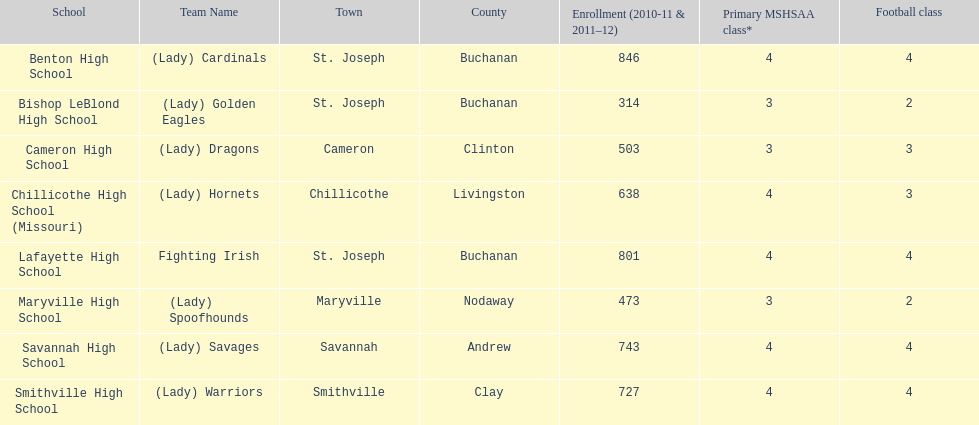How many of the schools had at least 500 students enrolled in the 2010-2011 and 2011-2012 season? 6. 